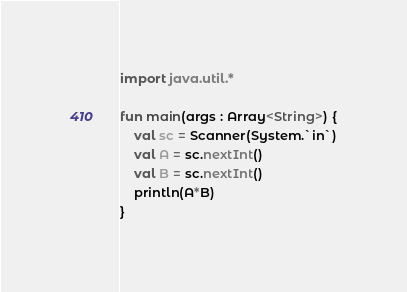<code> <loc_0><loc_0><loc_500><loc_500><_Kotlin_>import java.util.*

fun main(args : Array<String>) {
    val sc = Scanner(System.`in`)
    val A = sc.nextInt()
    val B = sc.nextInt()
    println(A*B)
}
</code> 